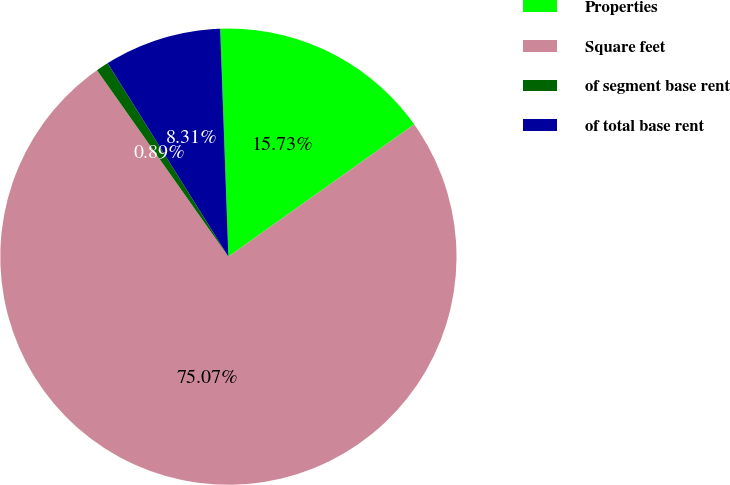Convert chart to OTSL. <chart><loc_0><loc_0><loc_500><loc_500><pie_chart><fcel>Properties<fcel>Square feet<fcel>of segment base rent<fcel>of total base rent<nl><fcel>15.73%<fcel>75.08%<fcel>0.89%<fcel>8.31%<nl></chart> 